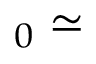Convert formula to latex. <formula><loc_0><loc_0><loc_500><loc_500>_ { 0 } \simeq</formula> 